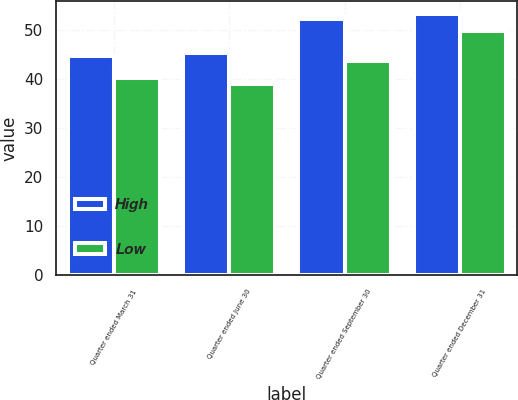Convert chart to OTSL. <chart><loc_0><loc_0><loc_500><loc_500><stacked_bar_chart><ecel><fcel>Quarter ended March 31<fcel>Quarter ended June 30<fcel>Quarter ended September 30<fcel>Quarter ended December 31<nl><fcel>High<fcel>44.61<fcel>45.33<fcel>52.11<fcel>53.14<nl><fcel>Low<fcel>40.1<fcel>38.86<fcel>43.7<fcel>49.61<nl></chart> 